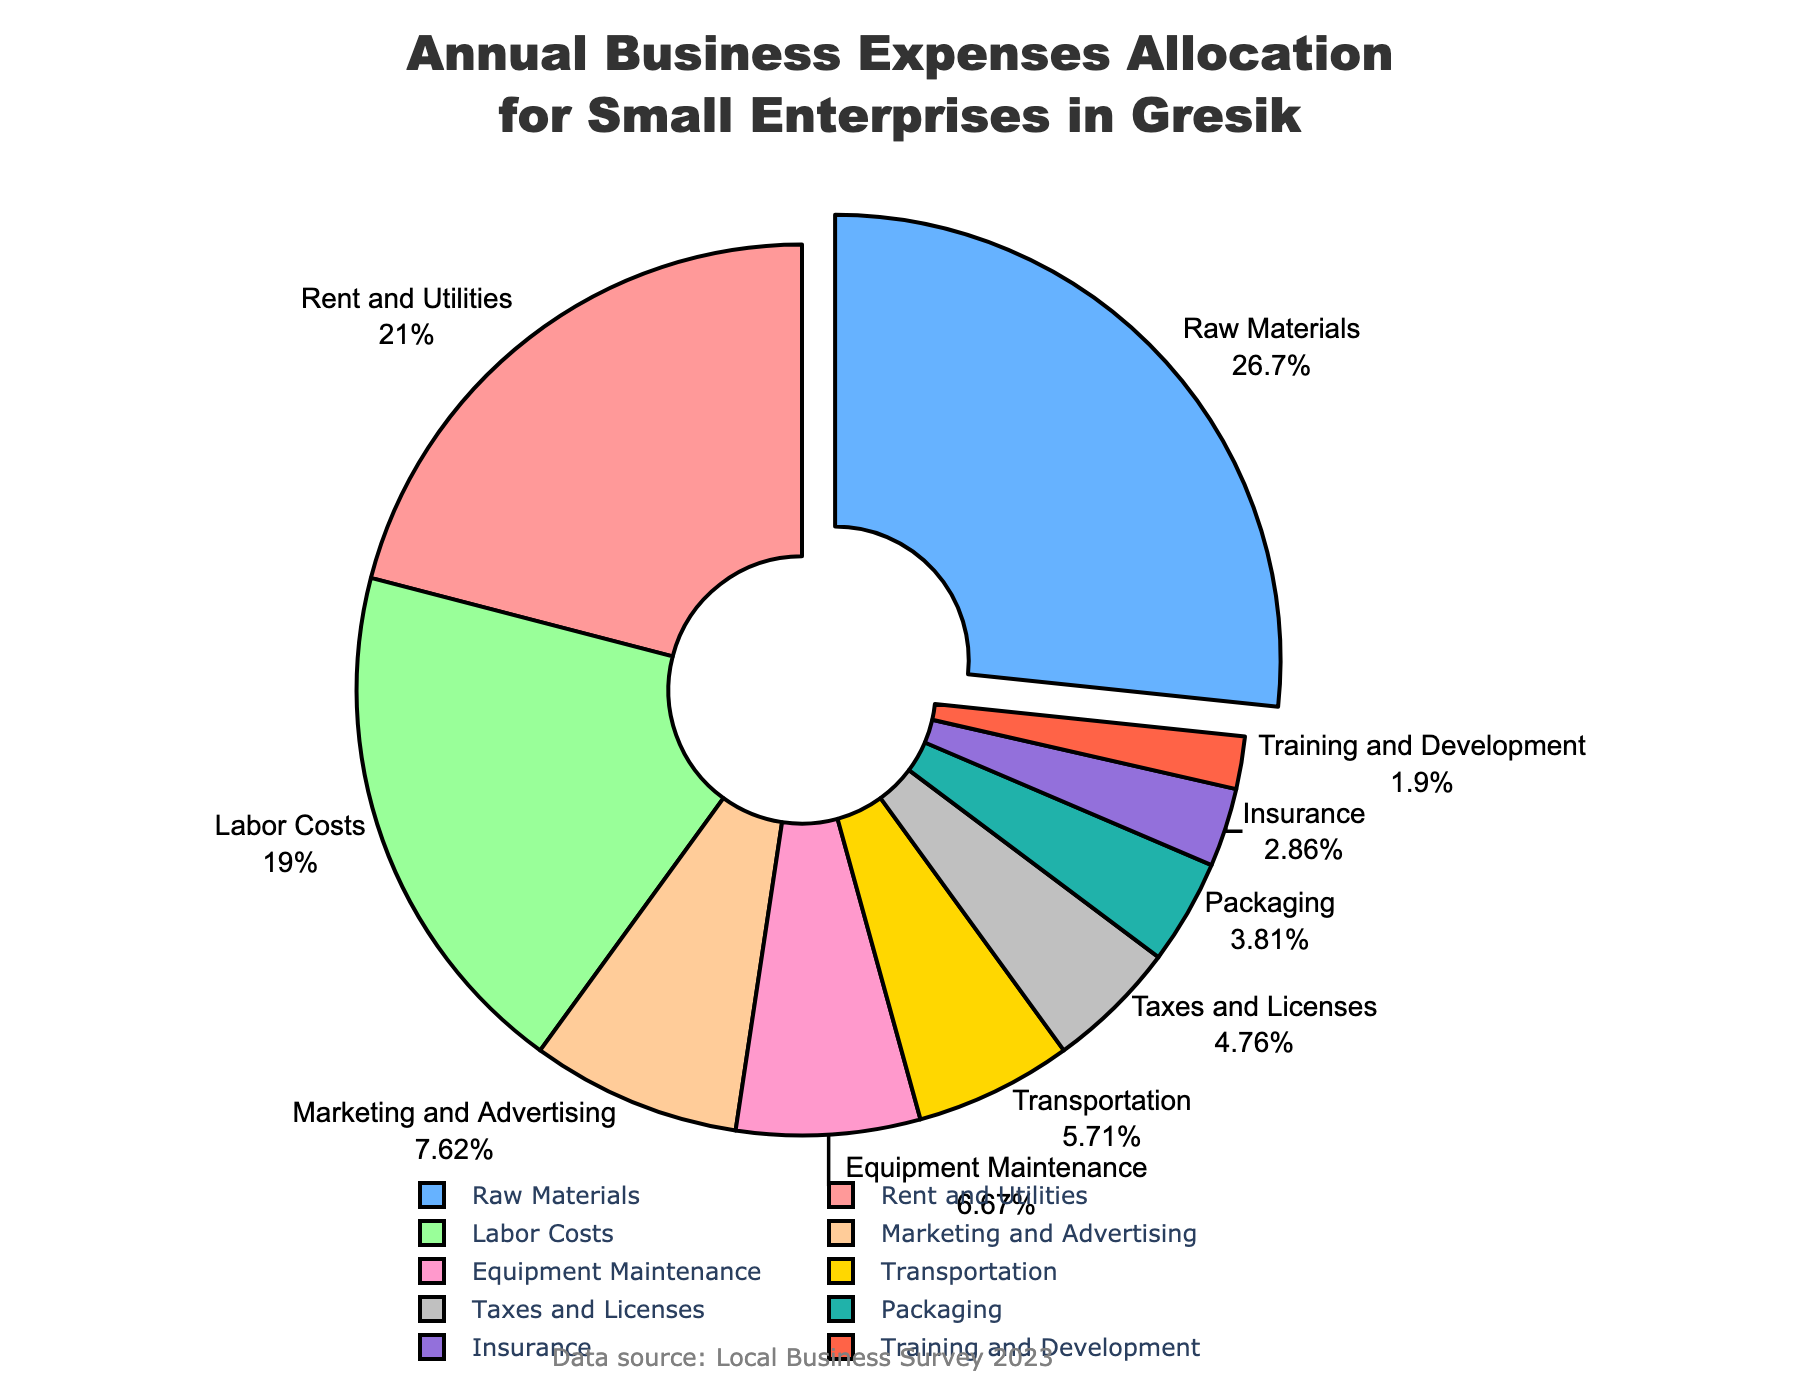What percentage is allocated to Rent and Utilities? Rent and Utilities have a segment on the pie chart. The percentage is clearly marked next to its label.
Answer: 22% Which expense category has the highest percentage allocation? By observing the pie chart, the largest segment is pulled out slightly from the pie. This segment is labeled with the highest percentage.
Answer: Raw Materials How much more is spent on Rent and Utilities compared to Equipment Maintenance? To find the difference, subtract the percentage for Equipment Maintenance from Rent and Utilities. Rent and Utilities is 22%, and Equipment Maintenance is 7%, so 22% - 7% = 15%.
Answer: 15% What are the top three expense categories by percentage? By looking at the relative sizes of the segments in the pie chart, we identify the three largest segments: Raw Materials, Rent and Utilities, and Labor Costs at 28%, 22%, and 20%, respectively.
Answer: Raw Materials, Rent and Utilities, Labor Costs What percentage is spent on Training and Development, and how does it compare to Taxes and Licenses? Training and Development is marked with 2%, and Taxes and Licenses are marked with 5%. Comparing them shows that Taxes and Licenses are higher.
Answer: Training and Development is 2%, and Taxes and Licenses is 5%, so Taxes and Licenses are 3% higher Calculate the total percentage of expenses allocated to Marketing and Advertising, Equipment Maintenance, and Transportation combined. Add the percentages for Marketing and Advertising (8%), Equipment Maintenance (7%), and Transportation (6%): 8% + 7% + 6% = 21%.
Answer: 21% Which categories have a percentage allocation that is less than the average allocation of all categories? First, calculate the average percentage allocation of all categories:
(22 + 28 + 20 + 8 + 7 + 6 + 5 + 3 + 4 + 2) / 10 = 10.5%. Categories below this average are: Marketing and Advertising (8%), Equipment Maintenance (7%), Transportation (6%), Taxes and Licenses (5%), Insurance (3%), Packaging (4%), and Training and Development (2%).
Answer: Marketing and Advertising, Equipment Maintenance, Transportation, Taxes and Licenses, Insurance, Packaging, Training and Development Identify the smallest expense category and its percentage. The pie chart displays the smallest segment which represents Training and Development. The percentage is labeled next to it.
Answer: Training and Development, 2% How much more is allocated to Raw Materials than to Labor Costs? Subtract the percentage for Labor Costs from Raw Materials. Raw Materials is 28%, and Labor Costs is 20%, so 28% - 20% = 8%.
Answer: 8% 